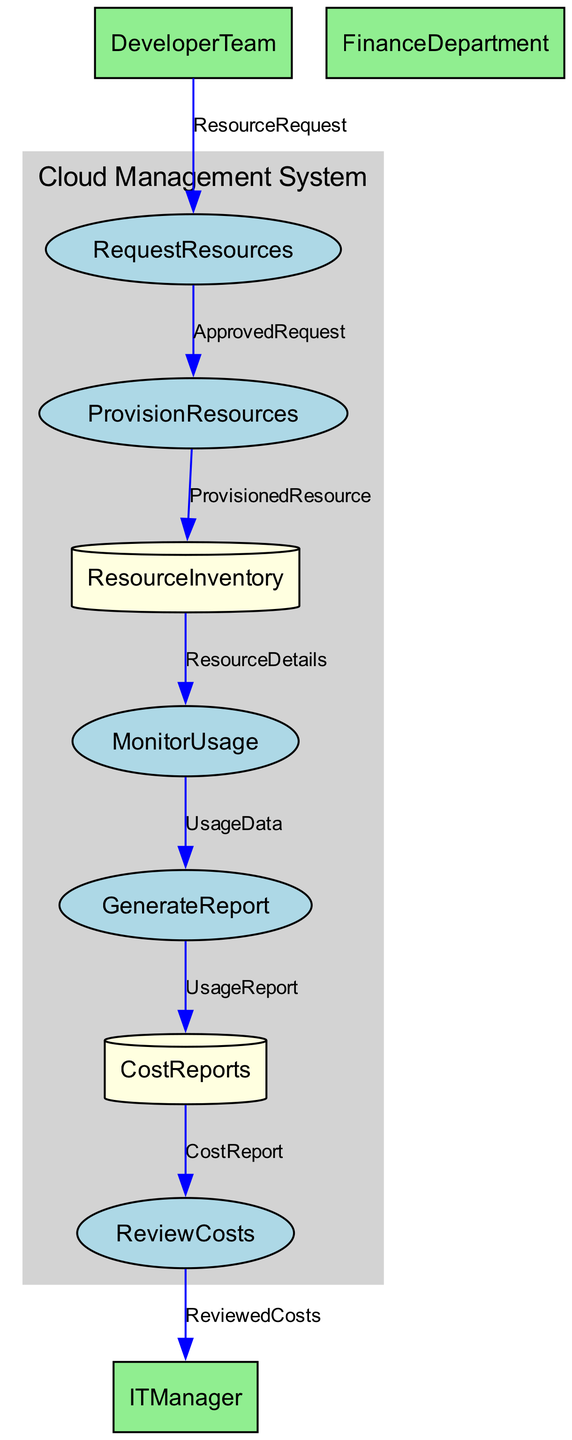What entity requests cloud resources? The "DeveloperTeam" is the entity that submits requests for cloud resources to the "RequestResources" process.
Answer: DeveloperTeam How many processes are shown in the diagram? There are five processes illustrated in the diagram: "RequestResources", "ProvisionResources", "MonitorUsage", "GenerateReport", and "ReviewCosts".
Answer: 5 What data flow connects "ProvisionResources" to "ResourceInventory"? The data flow labeled "ProvisionedResource" connects the "ProvisionResources" process to the "ResourceInventory" data store, indicating that provisioned resources are added to the inventory.
Answer: ProvisionedResource Which department reviews the cost reports? The "FinanceDepartment" is responsible for reviewing the cost reports generated by the ITManager.
Answer: FinanceDepartment What is the data flow from "CostReports" to "ReviewCosts"? The data flow from "CostReports" to "ReviewCosts" is labeled as "CostReport", which indicates that cost reports are sent to the finance department for review.
Answer: CostReport How does the "ITManager" monitor resource usage? The "ITManager" monitors resource usage through the "MonitorUsage" process, using details from the "ResourceInventory" data store that contain information about the allocated cloud resources.
Answer: MonitorUsage What are the two types of data stores in the diagram? The two data stores shown in the diagram are "ResourceInventory" and "CostReports", where one contains details of cloud resources and the other contains detailed cost reports.
Answer: ResourceInventory and CostReports Which process sends usage data for reporting? The "MonitorUsage" process compiles usage data and sends it to the "GenerateReport" process to create reports on resource usage.
Answer: MonitorUsage What type of system is represented in the boundary? The boundary labeled "CloudManagementSystem" encompasses the processes and data stores involved in managing cloud resources and their costs effectively.
Answer: CloudManagementSystem 